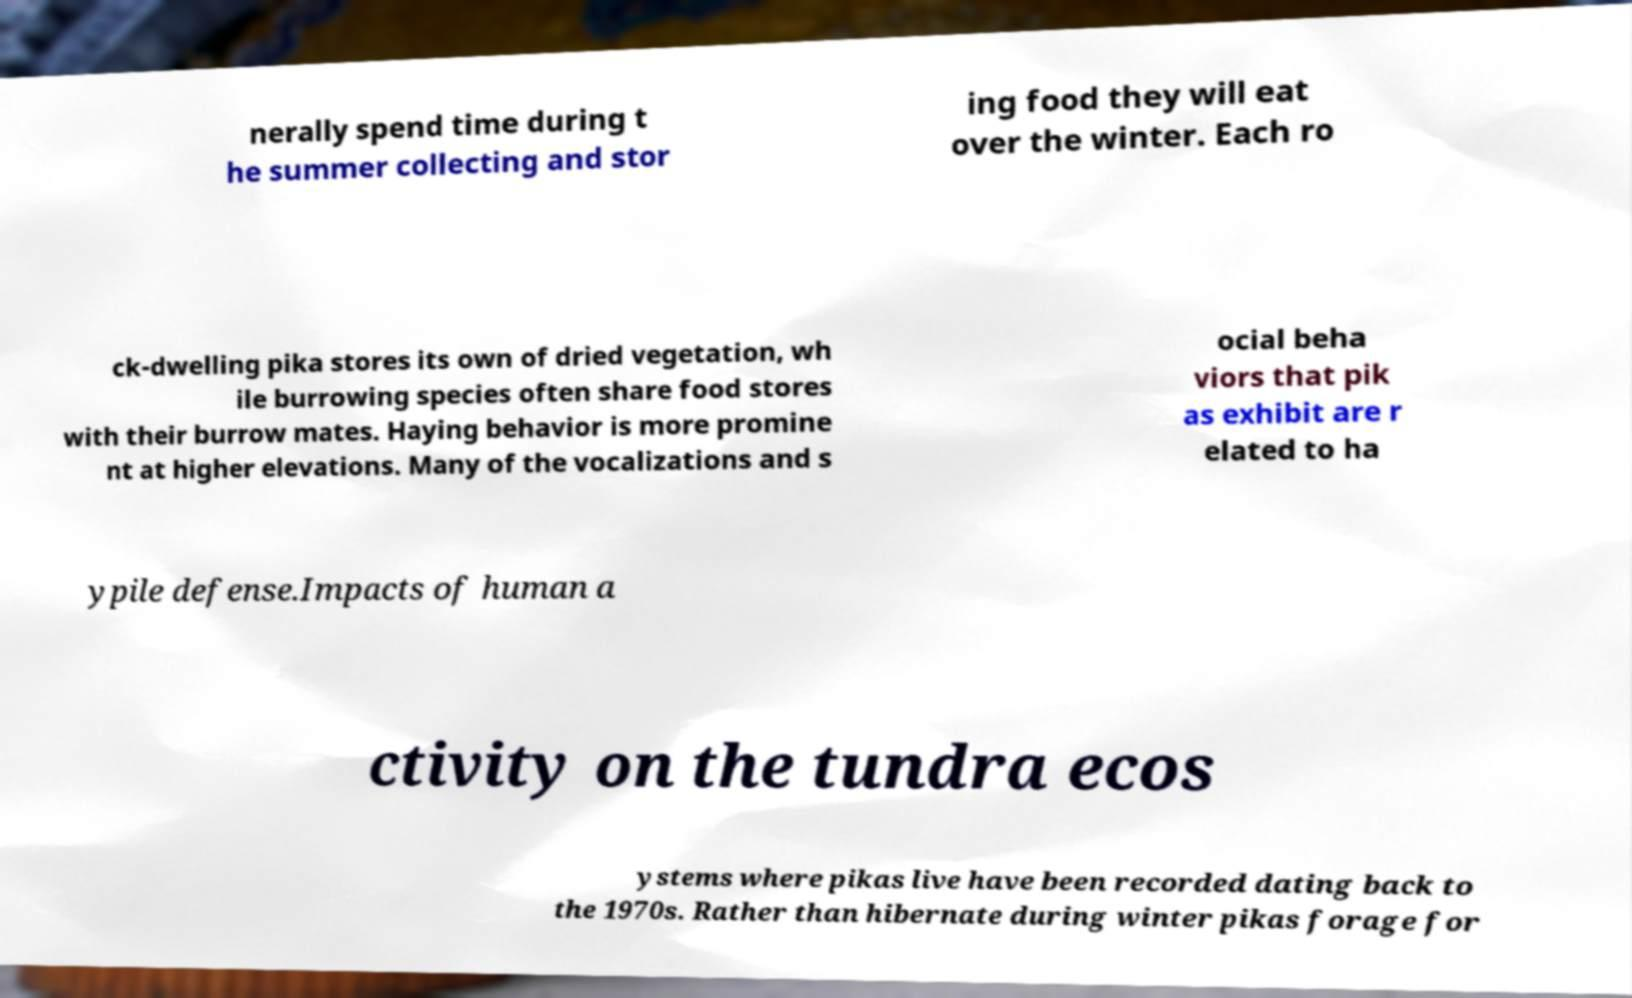Please read and relay the text visible in this image. What does it say? nerally spend time during t he summer collecting and stor ing food they will eat over the winter. Each ro ck-dwelling pika stores its own of dried vegetation, wh ile burrowing species often share food stores with their burrow mates. Haying behavior is more promine nt at higher elevations. Many of the vocalizations and s ocial beha viors that pik as exhibit are r elated to ha ypile defense.Impacts of human a ctivity on the tundra ecos ystems where pikas live have been recorded dating back to the 1970s. Rather than hibernate during winter pikas forage for 